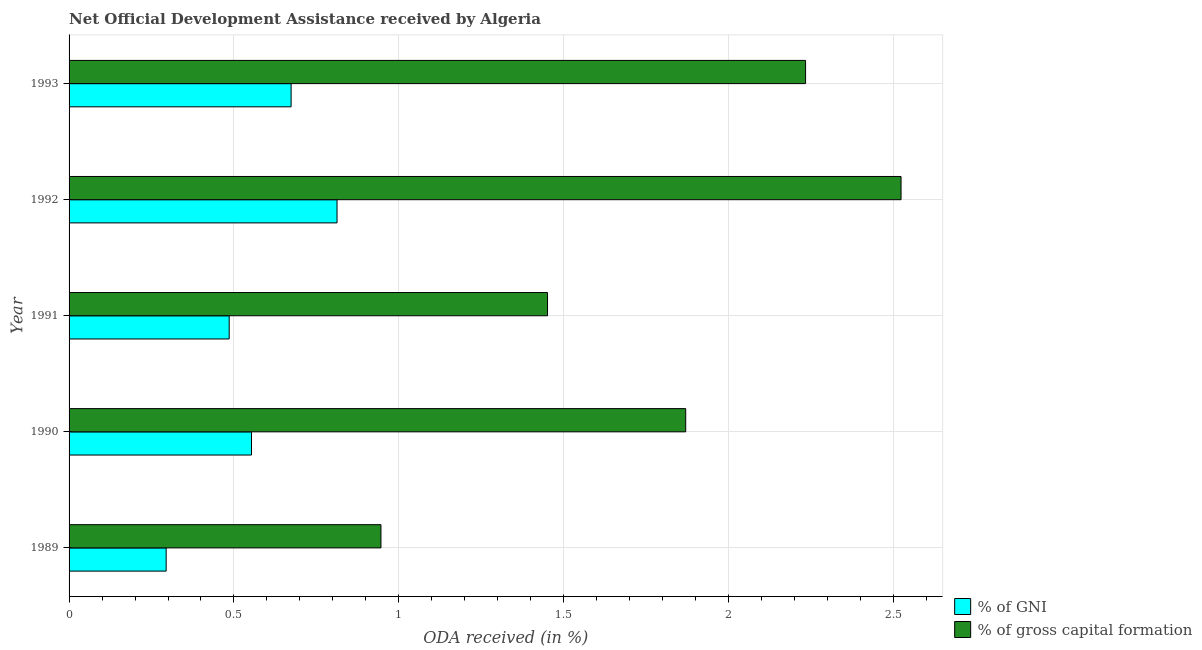How many groups of bars are there?
Provide a short and direct response. 5. Are the number of bars per tick equal to the number of legend labels?
Offer a terse response. Yes. How many bars are there on the 2nd tick from the bottom?
Provide a short and direct response. 2. What is the label of the 3rd group of bars from the top?
Give a very brief answer. 1991. In how many cases, is the number of bars for a given year not equal to the number of legend labels?
Keep it short and to the point. 0. What is the oda received as percentage of gross capital formation in 1993?
Keep it short and to the point. 2.23. Across all years, what is the maximum oda received as percentage of gross capital formation?
Ensure brevity in your answer.  2.52. Across all years, what is the minimum oda received as percentage of gross capital formation?
Offer a terse response. 0.95. What is the total oda received as percentage of gross capital formation in the graph?
Your answer should be very brief. 9.02. What is the difference between the oda received as percentage of gni in 1990 and that in 1993?
Offer a terse response. -0.12. What is the difference between the oda received as percentage of gni in 1990 and the oda received as percentage of gross capital formation in 1993?
Make the answer very short. -1.68. What is the average oda received as percentage of gni per year?
Ensure brevity in your answer.  0.56. In the year 1990, what is the difference between the oda received as percentage of gross capital formation and oda received as percentage of gni?
Offer a very short reply. 1.32. In how many years, is the oda received as percentage of gross capital formation greater than 0.6 %?
Give a very brief answer. 5. What is the ratio of the oda received as percentage of gross capital formation in 1991 to that in 1992?
Provide a short and direct response. 0.57. Is the oda received as percentage of gni in 1990 less than that in 1991?
Give a very brief answer. No. Is the difference between the oda received as percentage of gross capital formation in 1990 and 1992 greater than the difference between the oda received as percentage of gni in 1990 and 1992?
Your answer should be very brief. No. What is the difference between the highest and the second highest oda received as percentage of gross capital formation?
Give a very brief answer. 0.29. What is the difference between the highest and the lowest oda received as percentage of gross capital formation?
Offer a terse response. 1.58. In how many years, is the oda received as percentage of gross capital formation greater than the average oda received as percentage of gross capital formation taken over all years?
Your response must be concise. 3. Is the sum of the oda received as percentage of gross capital formation in 1991 and 1993 greater than the maximum oda received as percentage of gni across all years?
Your answer should be compact. Yes. What does the 1st bar from the top in 1992 represents?
Give a very brief answer. % of gross capital formation. What does the 1st bar from the bottom in 1991 represents?
Make the answer very short. % of GNI. How many years are there in the graph?
Provide a succinct answer. 5. What is the difference between two consecutive major ticks on the X-axis?
Your answer should be compact. 0.5. Are the values on the major ticks of X-axis written in scientific E-notation?
Provide a short and direct response. No. Does the graph contain any zero values?
Your answer should be compact. No. How are the legend labels stacked?
Provide a short and direct response. Vertical. What is the title of the graph?
Keep it short and to the point. Net Official Development Assistance received by Algeria. What is the label or title of the X-axis?
Your answer should be compact. ODA received (in %). What is the ODA received (in %) of % of GNI in 1989?
Your answer should be compact. 0.29. What is the ODA received (in %) in % of gross capital formation in 1989?
Keep it short and to the point. 0.95. What is the ODA received (in %) of % of GNI in 1990?
Provide a succinct answer. 0.55. What is the ODA received (in %) of % of gross capital formation in 1990?
Give a very brief answer. 1.87. What is the ODA received (in %) of % of GNI in 1991?
Offer a terse response. 0.49. What is the ODA received (in %) in % of gross capital formation in 1991?
Your answer should be compact. 1.45. What is the ODA received (in %) in % of GNI in 1992?
Keep it short and to the point. 0.81. What is the ODA received (in %) in % of gross capital formation in 1992?
Your response must be concise. 2.52. What is the ODA received (in %) in % of GNI in 1993?
Offer a terse response. 0.67. What is the ODA received (in %) in % of gross capital formation in 1993?
Your answer should be compact. 2.23. Across all years, what is the maximum ODA received (in %) of % of GNI?
Your answer should be compact. 0.81. Across all years, what is the maximum ODA received (in %) in % of gross capital formation?
Your answer should be compact. 2.52. Across all years, what is the minimum ODA received (in %) in % of GNI?
Make the answer very short. 0.29. Across all years, what is the minimum ODA received (in %) of % of gross capital formation?
Make the answer very short. 0.95. What is the total ODA received (in %) in % of GNI in the graph?
Offer a very short reply. 2.82. What is the total ODA received (in %) of % of gross capital formation in the graph?
Offer a very short reply. 9.02. What is the difference between the ODA received (in %) in % of GNI in 1989 and that in 1990?
Your answer should be very brief. -0.26. What is the difference between the ODA received (in %) in % of gross capital formation in 1989 and that in 1990?
Offer a terse response. -0.92. What is the difference between the ODA received (in %) of % of GNI in 1989 and that in 1991?
Provide a succinct answer. -0.19. What is the difference between the ODA received (in %) of % of gross capital formation in 1989 and that in 1991?
Provide a succinct answer. -0.51. What is the difference between the ODA received (in %) in % of GNI in 1989 and that in 1992?
Give a very brief answer. -0.52. What is the difference between the ODA received (in %) of % of gross capital formation in 1989 and that in 1992?
Offer a terse response. -1.58. What is the difference between the ODA received (in %) of % of GNI in 1989 and that in 1993?
Offer a terse response. -0.38. What is the difference between the ODA received (in %) in % of gross capital formation in 1989 and that in 1993?
Make the answer very short. -1.29. What is the difference between the ODA received (in %) of % of GNI in 1990 and that in 1991?
Your answer should be compact. 0.07. What is the difference between the ODA received (in %) in % of gross capital formation in 1990 and that in 1991?
Provide a succinct answer. 0.42. What is the difference between the ODA received (in %) of % of GNI in 1990 and that in 1992?
Provide a short and direct response. -0.26. What is the difference between the ODA received (in %) of % of gross capital formation in 1990 and that in 1992?
Offer a very short reply. -0.65. What is the difference between the ODA received (in %) in % of GNI in 1990 and that in 1993?
Your response must be concise. -0.12. What is the difference between the ODA received (in %) of % of gross capital formation in 1990 and that in 1993?
Ensure brevity in your answer.  -0.36. What is the difference between the ODA received (in %) of % of GNI in 1991 and that in 1992?
Offer a very short reply. -0.33. What is the difference between the ODA received (in %) of % of gross capital formation in 1991 and that in 1992?
Your answer should be compact. -1.07. What is the difference between the ODA received (in %) in % of GNI in 1991 and that in 1993?
Make the answer very short. -0.19. What is the difference between the ODA received (in %) in % of gross capital formation in 1991 and that in 1993?
Provide a succinct answer. -0.78. What is the difference between the ODA received (in %) of % of GNI in 1992 and that in 1993?
Your answer should be compact. 0.14. What is the difference between the ODA received (in %) of % of gross capital formation in 1992 and that in 1993?
Make the answer very short. 0.29. What is the difference between the ODA received (in %) in % of GNI in 1989 and the ODA received (in %) in % of gross capital formation in 1990?
Offer a terse response. -1.58. What is the difference between the ODA received (in %) in % of GNI in 1989 and the ODA received (in %) in % of gross capital formation in 1991?
Your answer should be compact. -1.16. What is the difference between the ODA received (in %) of % of GNI in 1989 and the ODA received (in %) of % of gross capital formation in 1992?
Offer a very short reply. -2.23. What is the difference between the ODA received (in %) of % of GNI in 1989 and the ODA received (in %) of % of gross capital formation in 1993?
Ensure brevity in your answer.  -1.94. What is the difference between the ODA received (in %) in % of GNI in 1990 and the ODA received (in %) in % of gross capital formation in 1991?
Make the answer very short. -0.9. What is the difference between the ODA received (in %) of % of GNI in 1990 and the ODA received (in %) of % of gross capital formation in 1992?
Ensure brevity in your answer.  -1.97. What is the difference between the ODA received (in %) of % of GNI in 1990 and the ODA received (in %) of % of gross capital formation in 1993?
Keep it short and to the point. -1.68. What is the difference between the ODA received (in %) of % of GNI in 1991 and the ODA received (in %) of % of gross capital formation in 1992?
Keep it short and to the point. -2.04. What is the difference between the ODA received (in %) in % of GNI in 1991 and the ODA received (in %) in % of gross capital formation in 1993?
Provide a short and direct response. -1.75. What is the difference between the ODA received (in %) in % of GNI in 1992 and the ODA received (in %) in % of gross capital formation in 1993?
Keep it short and to the point. -1.42. What is the average ODA received (in %) of % of GNI per year?
Ensure brevity in your answer.  0.56. What is the average ODA received (in %) of % of gross capital formation per year?
Give a very brief answer. 1.8. In the year 1989, what is the difference between the ODA received (in %) of % of GNI and ODA received (in %) of % of gross capital formation?
Make the answer very short. -0.65. In the year 1990, what is the difference between the ODA received (in %) of % of GNI and ODA received (in %) of % of gross capital formation?
Your answer should be very brief. -1.32. In the year 1991, what is the difference between the ODA received (in %) of % of GNI and ODA received (in %) of % of gross capital formation?
Offer a terse response. -0.97. In the year 1992, what is the difference between the ODA received (in %) in % of GNI and ODA received (in %) in % of gross capital formation?
Keep it short and to the point. -1.71. In the year 1993, what is the difference between the ODA received (in %) in % of GNI and ODA received (in %) in % of gross capital formation?
Your answer should be very brief. -1.56. What is the ratio of the ODA received (in %) of % of GNI in 1989 to that in 1990?
Offer a very short reply. 0.53. What is the ratio of the ODA received (in %) in % of gross capital formation in 1989 to that in 1990?
Provide a succinct answer. 0.51. What is the ratio of the ODA received (in %) of % of GNI in 1989 to that in 1991?
Your answer should be very brief. 0.61. What is the ratio of the ODA received (in %) of % of gross capital formation in 1989 to that in 1991?
Ensure brevity in your answer.  0.65. What is the ratio of the ODA received (in %) of % of GNI in 1989 to that in 1992?
Offer a very short reply. 0.36. What is the ratio of the ODA received (in %) in % of gross capital formation in 1989 to that in 1992?
Your answer should be very brief. 0.37. What is the ratio of the ODA received (in %) in % of GNI in 1989 to that in 1993?
Make the answer very short. 0.44. What is the ratio of the ODA received (in %) of % of gross capital formation in 1989 to that in 1993?
Your response must be concise. 0.42. What is the ratio of the ODA received (in %) in % of GNI in 1990 to that in 1991?
Offer a terse response. 1.14. What is the ratio of the ODA received (in %) in % of gross capital formation in 1990 to that in 1991?
Give a very brief answer. 1.29. What is the ratio of the ODA received (in %) of % of GNI in 1990 to that in 1992?
Your response must be concise. 0.68. What is the ratio of the ODA received (in %) in % of gross capital formation in 1990 to that in 1992?
Your answer should be very brief. 0.74. What is the ratio of the ODA received (in %) of % of GNI in 1990 to that in 1993?
Make the answer very short. 0.82. What is the ratio of the ODA received (in %) in % of gross capital formation in 1990 to that in 1993?
Give a very brief answer. 0.84. What is the ratio of the ODA received (in %) in % of GNI in 1991 to that in 1992?
Ensure brevity in your answer.  0.6. What is the ratio of the ODA received (in %) of % of gross capital formation in 1991 to that in 1992?
Provide a short and direct response. 0.58. What is the ratio of the ODA received (in %) of % of GNI in 1991 to that in 1993?
Keep it short and to the point. 0.72. What is the ratio of the ODA received (in %) in % of gross capital formation in 1991 to that in 1993?
Keep it short and to the point. 0.65. What is the ratio of the ODA received (in %) in % of GNI in 1992 to that in 1993?
Offer a very short reply. 1.21. What is the ratio of the ODA received (in %) of % of gross capital formation in 1992 to that in 1993?
Give a very brief answer. 1.13. What is the difference between the highest and the second highest ODA received (in %) of % of GNI?
Make the answer very short. 0.14. What is the difference between the highest and the second highest ODA received (in %) of % of gross capital formation?
Ensure brevity in your answer.  0.29. What is the difference between the highest and the lowest ODA received (in %) in % of GNI?
Make the answer very short. 0.52. What is the difference between the highest and the lowest ODA received (in %) of % of gross capital formation?
Keep it short and to the point. 1.58. 